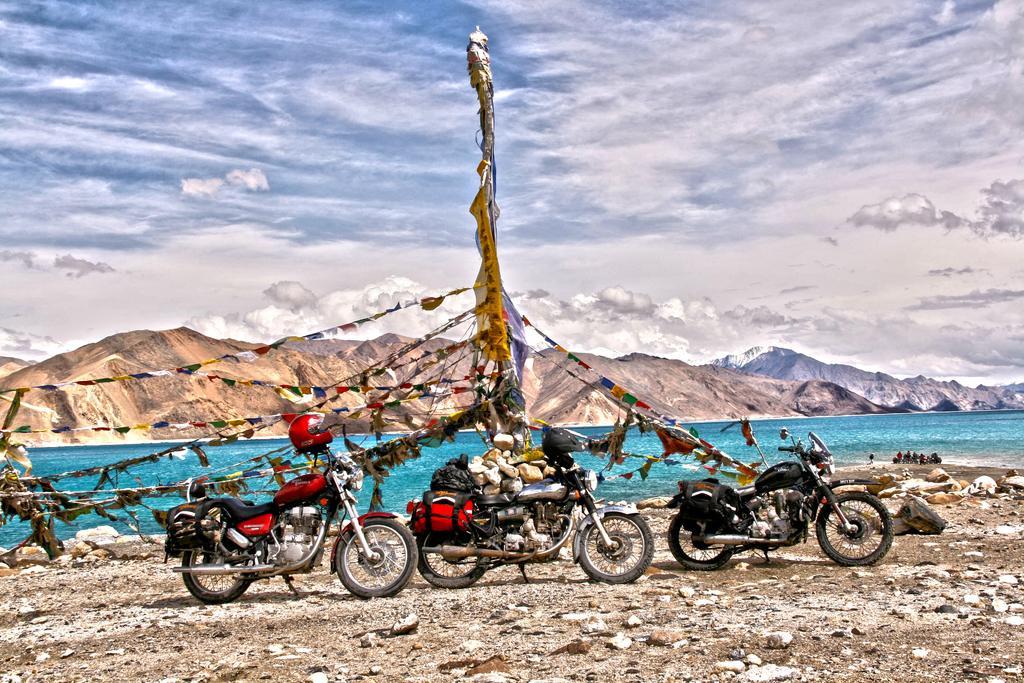Please provide a concise description of this image. In this image we can see many mountains. There is a lake in the image. There is a cloudy sky in the image. There are three motorbikes and few objects attached to it. There is an object and many flags attached to it. There are many rocks in the image. 